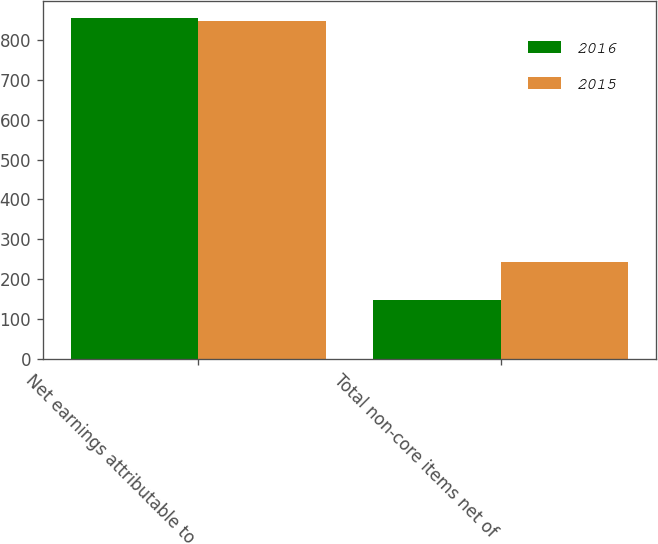Convert chart. <chart><loc_0><loc_0><loc_500><loc_500><stacked_bar_chart><ecel><fcel>Net earnings attributable to<fcel>Total non-core items net of<nl><fcel>2016<fcel>854<fcel>149<nl><fcel>2015<fcel>848<fcel>243<nl></chart> 